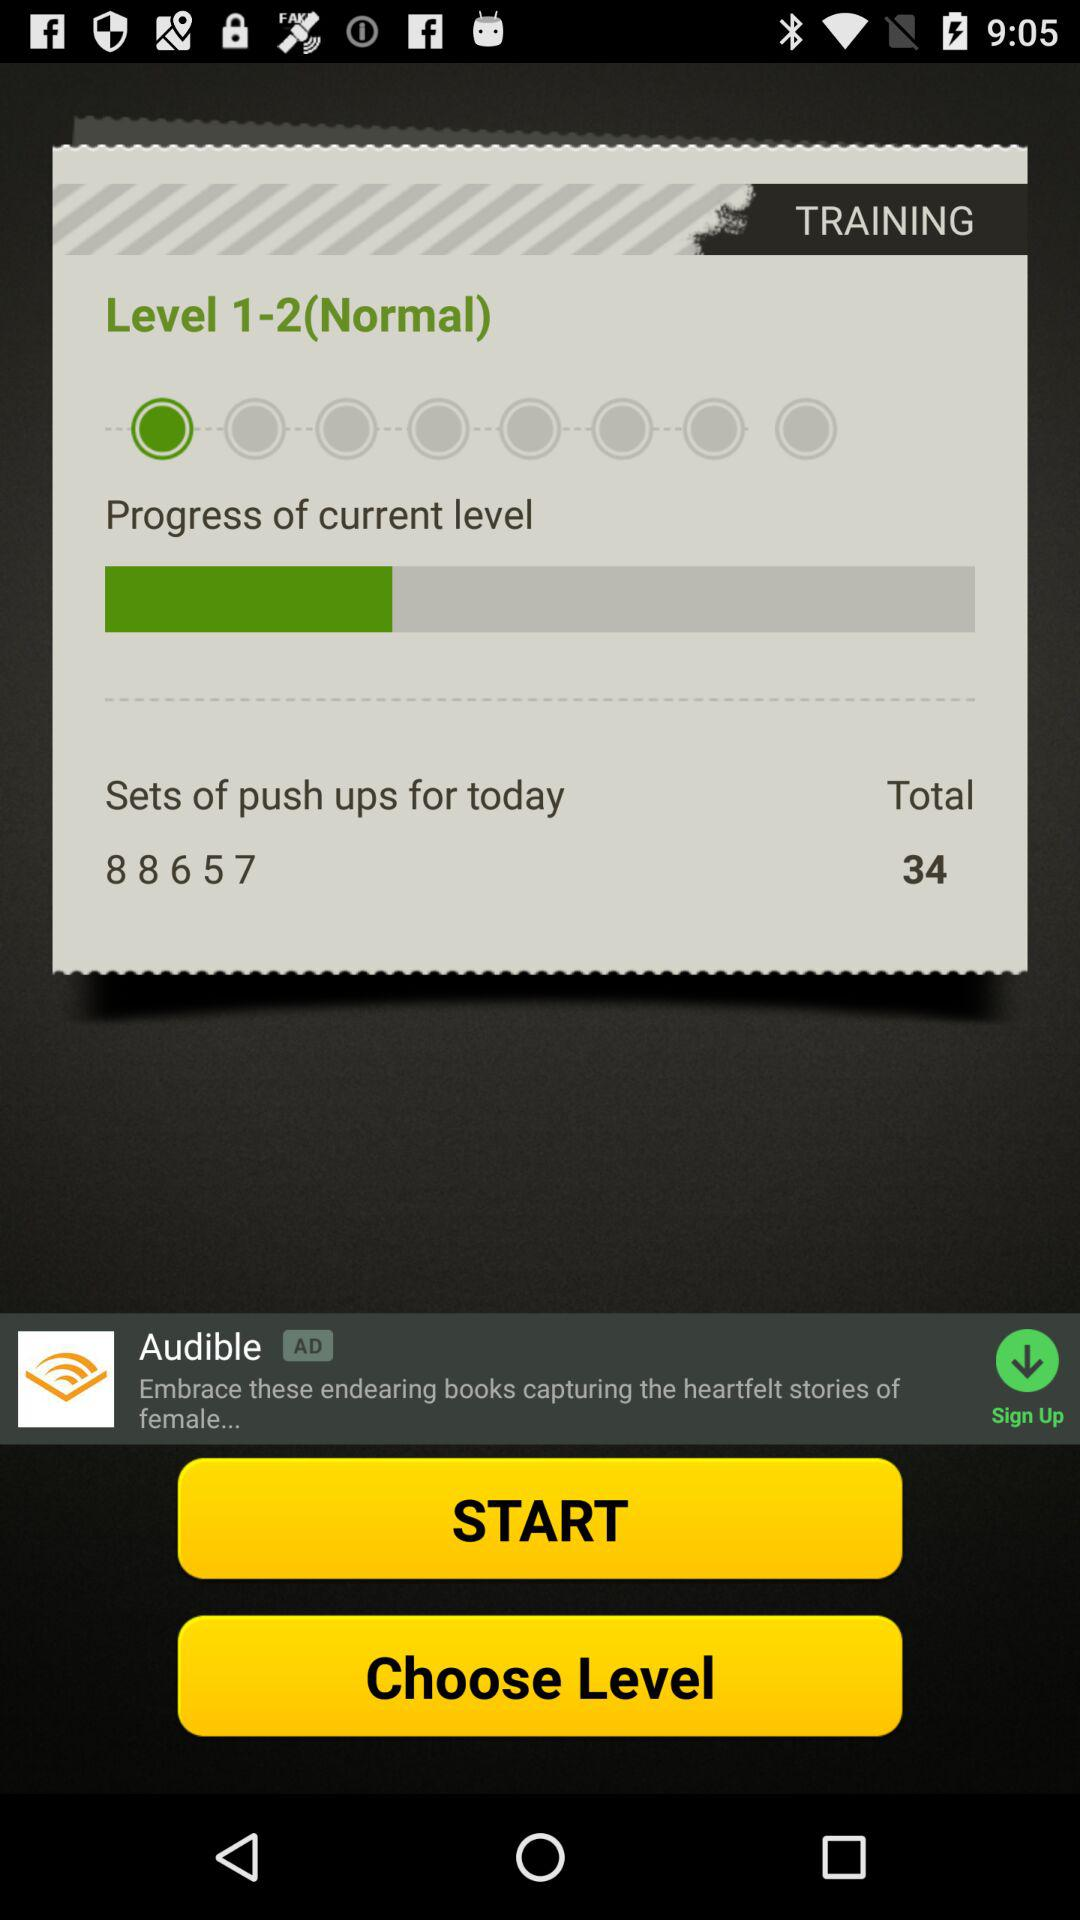What is the progress of current level?
When the provided information is insufficient, respond with <no answer>. <no answer> 